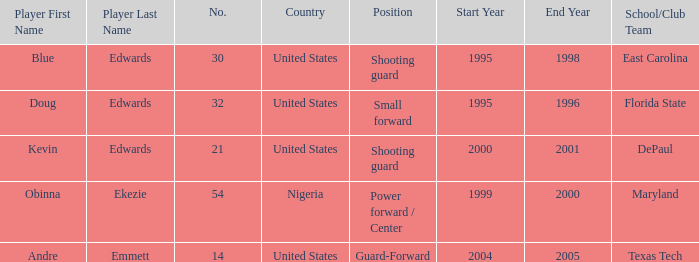When did no. 32 play for grizzles 1995-1996. 